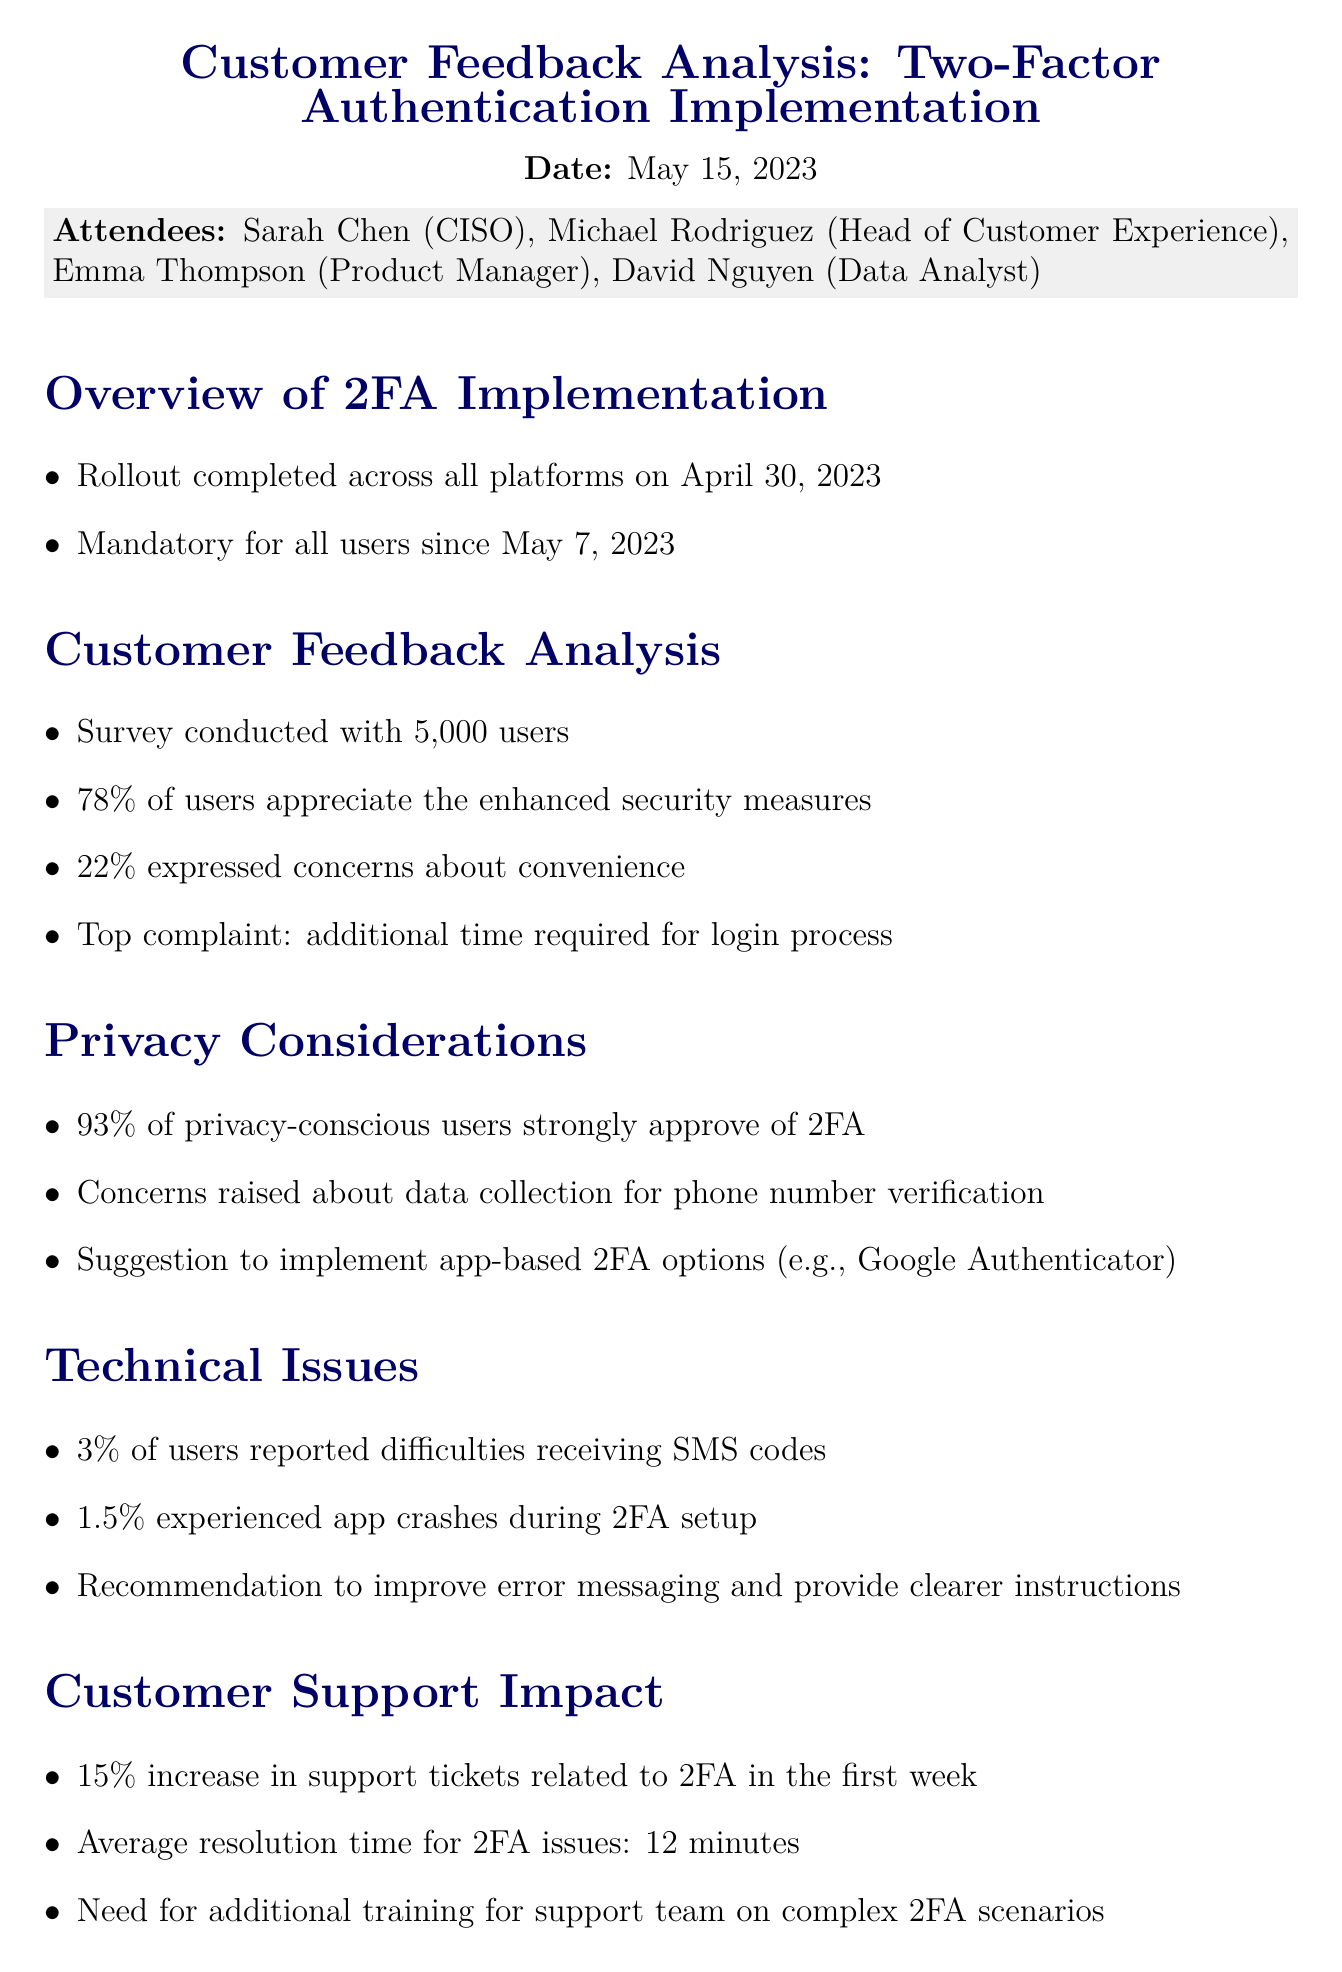What is the date of the meeting? The date of the meeting is specified at the beginning of the document.
Answer: May 15, 2023 Who is the Chief Information Security Officer? The document lists the attendees along with their titles, identifying the Chief Information Security Officer.
Answer: Sarah Chen What percentage of users appreciate the enhanced security measures? This information is found in the customer feedback analysis section, indicating user appreciation.
Answer: 78% What was the top complaint from users regarding 2FA? The document details customer feedback, highlighting the most common complaint.
Answer: Additional time required for login process What percentage of users reported difficulties receiving SMS codes? The technical issues section provides this specific statistic regarding user experiences.
Answer: 3% What is one suggestion made for improving 2FA? The privacy considerations section outlines suggestions related to privacy and user experience.
Answer: Implement app-based 2FA options What is the increase in support tickets related to 2FA in the first week? This detail is given in the customer support impact section, showing the effect of the implementation.
Answer: 15% What is the average resolution time for 2FA issues? This information can be found in the customer support impact section describing operational metrics.
Answer: 12 minutes 